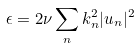<formula> <loc_0><loc_0><loc_500><loc_500>\epsilon = 2 \nu \sum _ { n } k _ { n } ^ { 2 } | u _ { n } | ^ { 2 }</formula> 